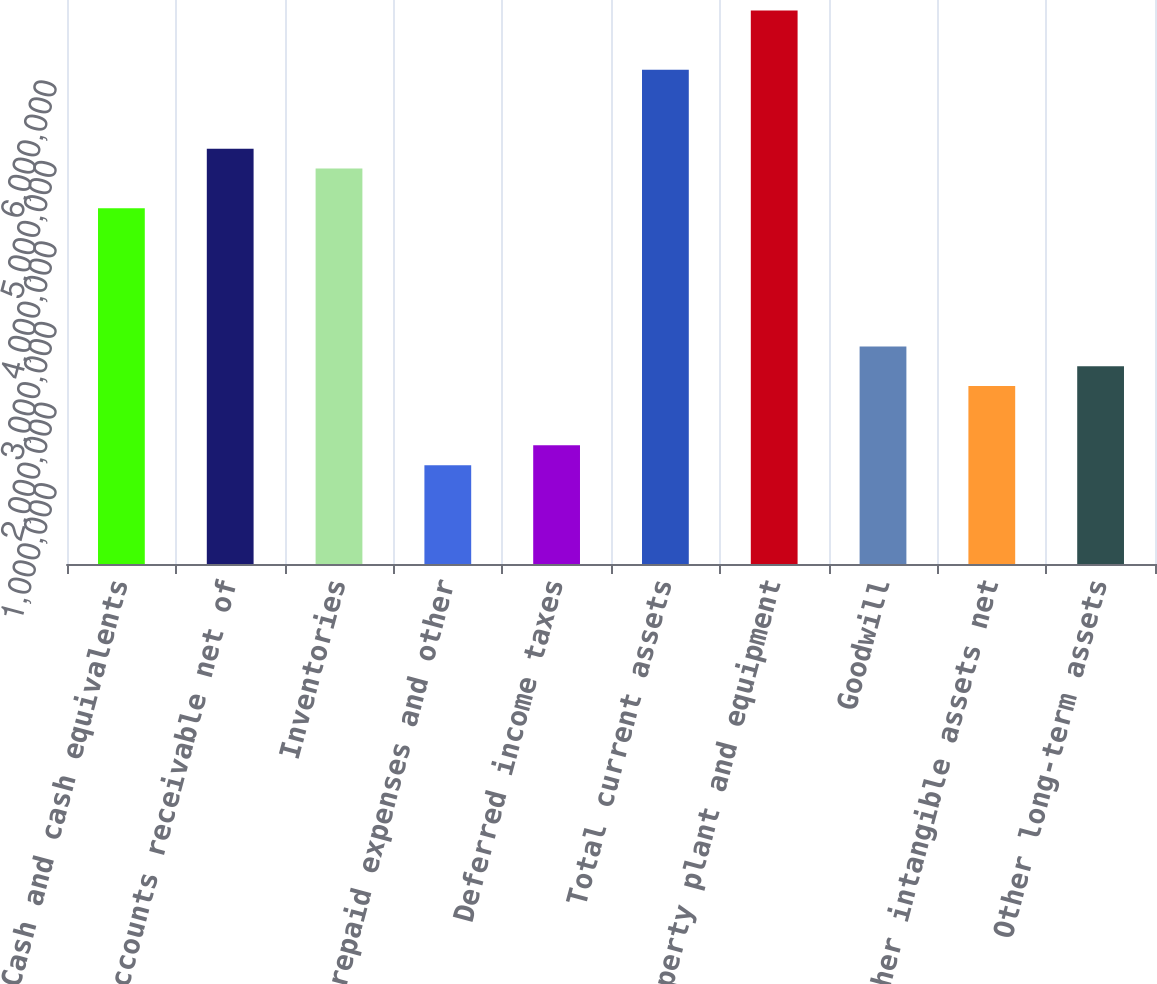Convert chart to OTSL. <chart><loc_0><loc_0><loc_500><loc_500><bar_chart><fcel>Cash and cash equivalents<fcel>Accounts receivable net of<fcel>Inventories<fcel>Prepaid expenses and other<fcel>Deferred income taxes<fcel>Total current assets<fcel>Property plant and equipment<fcel>Goodwill<fcel>Other intangible assets net<fcel>Other long-term assets<nl><fcel>4.41647e+06<fcel>5.15248e+06<fcel>4.90714e+06<fcel>1.22708e+06<fcel>1.47242e+06<fcel>6.13383e+06<fcel>6.86984e+06<fcel>2.69911e+06<fcel>2.20843e+06<fcel>2.45377e+06<nl></chart> 